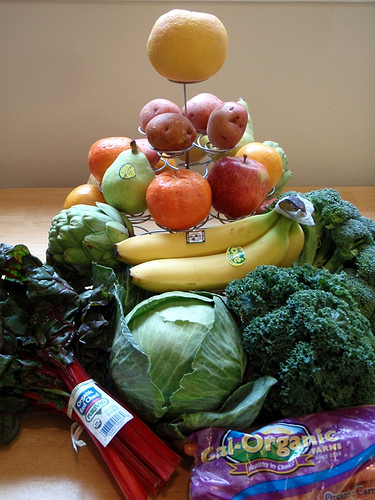Identify and read out the text in this image. Organic Cal 